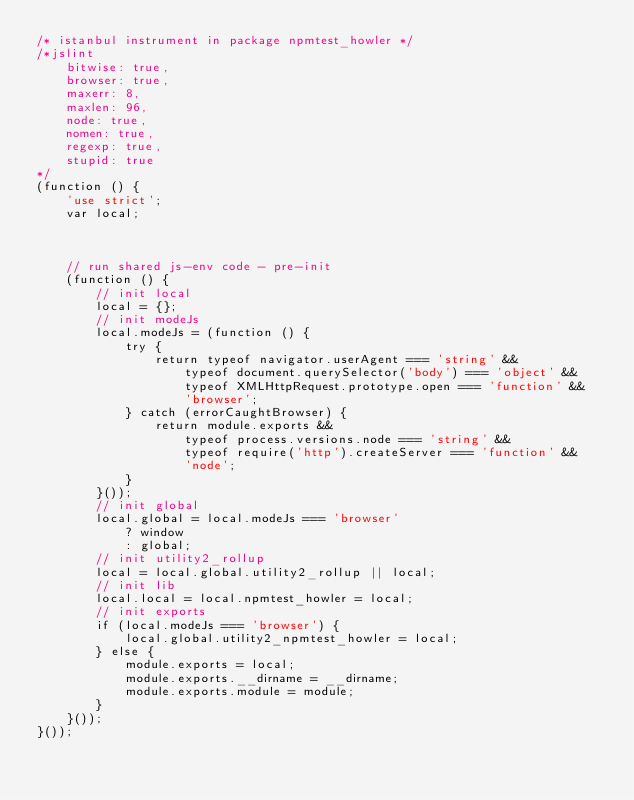<code> <loc_0><loc_0><loc_500><loc_500><_JavaScript_>/* istanbul instrument in package npmtest_howler */
/*jslint
    bitwise: true,
    browser: true,
    maxerr: 8,
    maxlen: 96,
    node: true,
    nomen: true,
    regexp: true,
    stupid: true
*/
(function () {
    'use strict';
    var local;



    // run shared js-env code - pre-init
    (function () {
        // init local
        local = {};
        // init modeJs
        local.modeJs = (function () {
            try {
                return typeof navigator.userAgent === 'string' &&
                    typeof document.querySelector('body') === 'object' &&
                    typeof XMLHttpRequest.prototype.open === 'function' &&
                    'browser';
            } catch (errorCaughtBrowser) {
                return module.exports &&
                    typeof process.versions.node === 'string' &&
                    typeof require('http').createServer === 'function' &&
                    'node';
            }
        }());
        // init global
        local.global = local.modeJs === 'browser'
            ? window
            : global;
        // init utility2_rollup
        local = local.global.utility2_rollup || local;
        // init lib
        local.local = local.npmtest_howler = local;
        // init exports
        if (local.modeJs === 'browser') {
            local.global.utility2_npmtest_howler = local;
        } else {
            module.exports = local;
            module.exports.__dirname = __dirname;
            module.exports.module = module;
        }
    }());
}());
</code> 